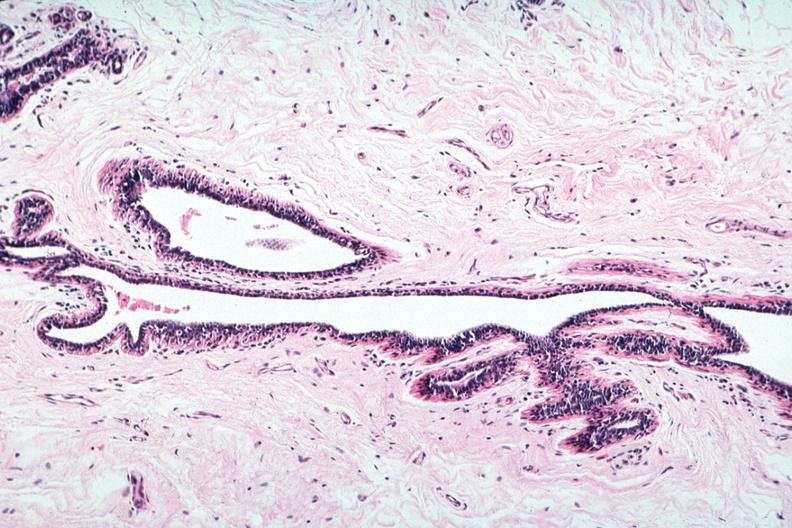does this image show normal duct in postmenopausal woman?
Answer the question using a single word or phrase. Yes 